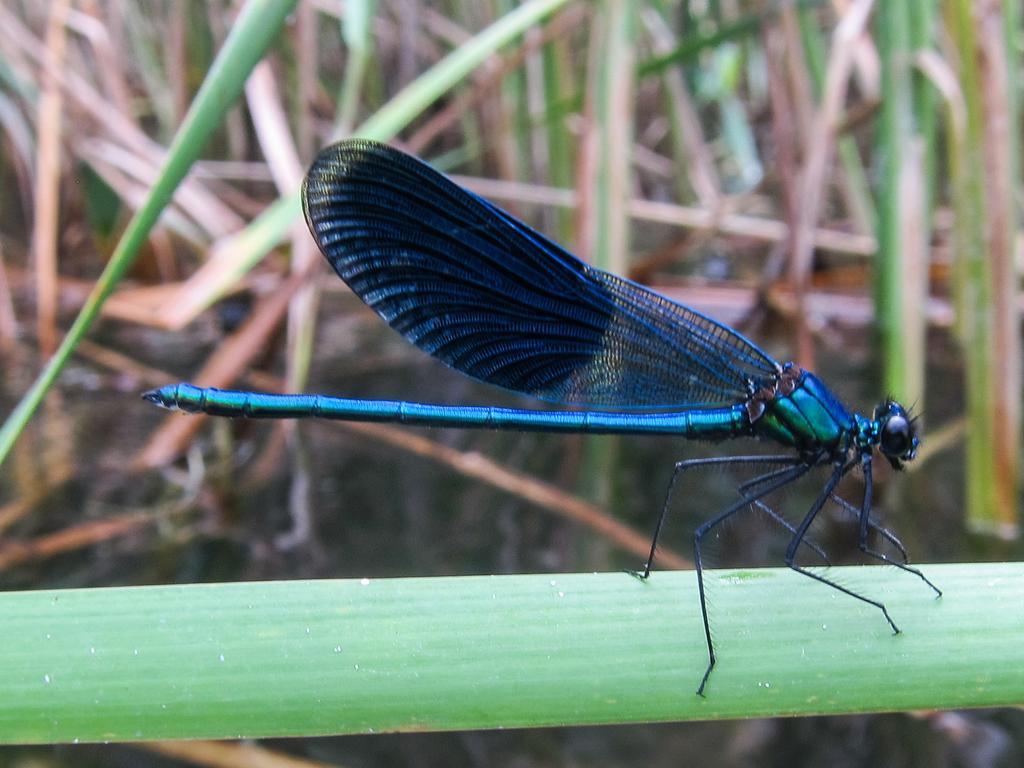Describe this image in one or two sentences. In this image I can see a dragon fly on the leaf, at the top there are green leaves. 